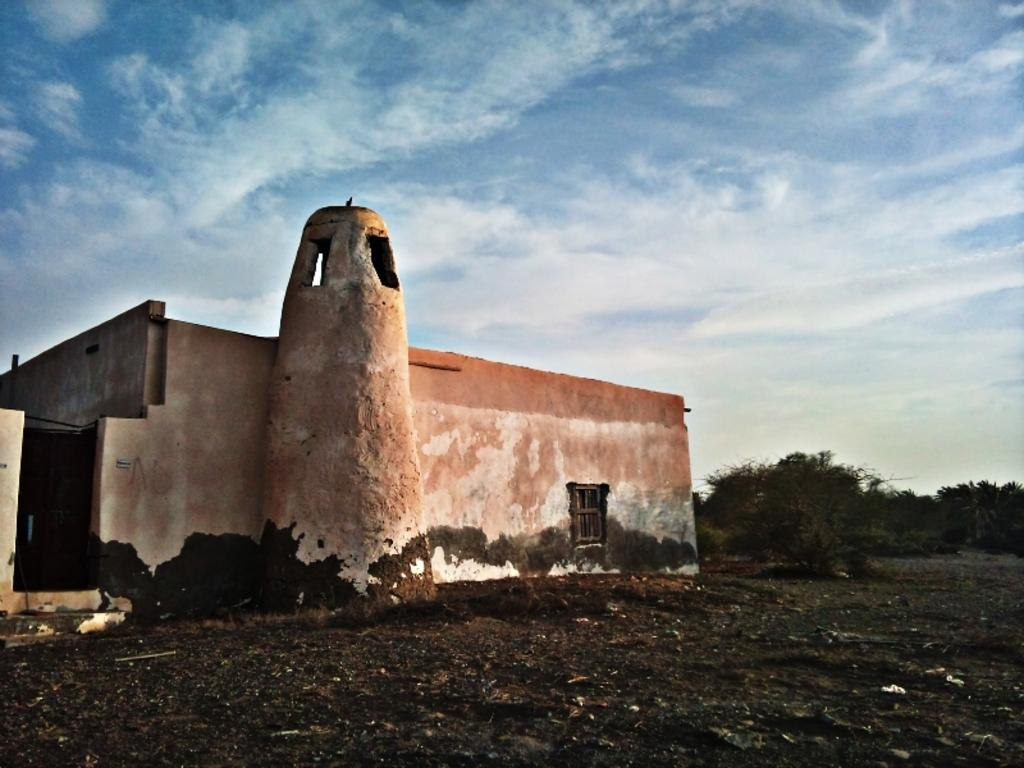What type of surface is visible in the image? There is ground visible in the image. What type of structure can be seen in the image? There is a building in the image. What colors are used to paint the building? The building is orange, cream, and black in color. What type of vegetation is present in the image? There are trees in the image. What is visible in the background of the image? The sky is visible in the background of the image. How many legs can be seen on the zoo animals in the image? There are no zoo animals present in the image, so it is not possible to determine the number of legs. What shape is the building in the image? The shape of the building is not mentioned in the facts provided, so it cannot be determined from the image. 